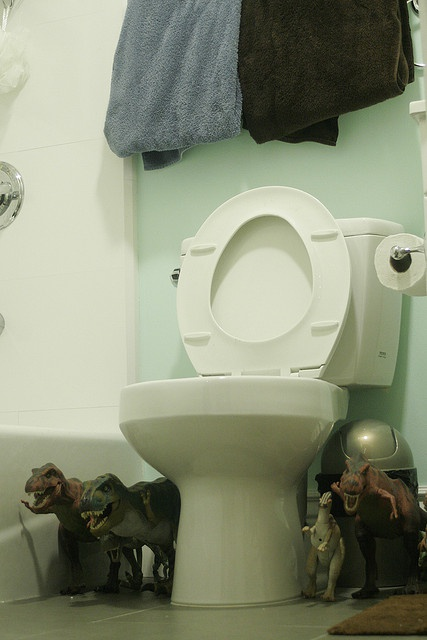Describe the objects in this image and their specific colors. I can see a toilet in darkgray, beige, gray, and olive tones in this image. 